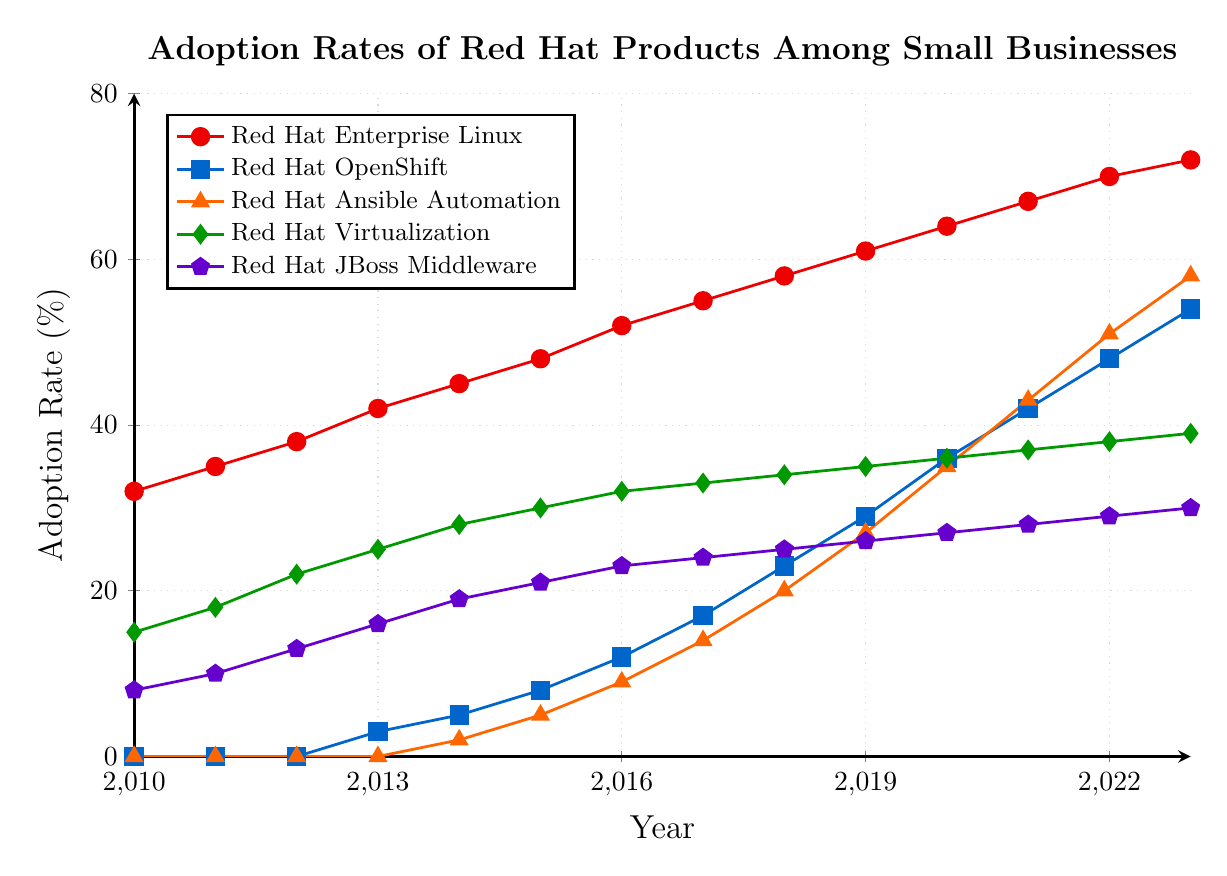What's the adoption rate of Red Hat Enterprise Linux in 2020? Locate the line corresponding to Red Hat Enterprise Linux and find the value at the year 2020, which is marked with a circular point. The y-axis value for this point is 64%.
Answer: 64% Which product had the lowest adoption rate in 2014? Compare the y-axis values for all product lines in the year 2014. Red Hat OpenShift had 5%, Red Hat Ansible Automation had 2%, Red Hat Virtualization had 28%, Red Hat JBoss Middleware had 19%, and Red Hat Enterprise Linux had 45%. The lowest is Red Hat Ansible Automation with 2%.
Answer: Red Hat Ansible Automation How does the adoption rate of Red Hat OpenShift in 2023 compare to that in 2015? The adoption rate of Red Hat OpenShift in 2023 is 54%, and in 2015 it is 8%. The adoption rate increased by 46%.
Answer: Increased by 46% Which product showed the greatest increase in adoption rate from 2010 to 2023? Calculate the difference in adoption rates from 2010 to 2023 for each product:
- Red Hat Enterprise Linux: 72 - 32 = 40%
- Red Hat OpenShift: 54 - 0 = 54%
- Red Hat Ansible Automation: 58 - 0 = 58%
- Red Hat Virtualization: 39 - 15 = 24%
- Red Hat JBoss Middleware: 30 - 8 = 22%
The greatest increase is in Red Hat Ansible Automation with an increase of 58%.
Answer: Red Hat Ansible Automation What is the average adoption rate of Red Hat Virtualization over the years 2018 to 2023? Sum the adoption rates for Red Hat Virtualization from 2018 to 2023: (34 + 35 + 36 + 37 + 38 + 39) = 219. Divide by the number of years, which is 6. So, the average is 219 / 6 ≈ 36.5%.
Answer: 36.5% Did any product other than Red Hat Ansible Automation have an adoption rate of 0% in any year after 2010? Review the lines for each product. Red Hat OpenShift had 0% until 2012, but after that, no product other than Red Hat Ansible Automation had 0% adoption rate.
Answer: No By how much did the adoption rate of Red Hat JBoss Middleware change between 2011 and 2021? The adoption rate of Red Hat JBoss Middleware in 2011 was 10%, and in 2021 it was 28%. The change is 28 - 10 = 18%.
Answer: 18% Which year did Red Hat Enterprise Linux first exceed an adoption rate of 50%? Follow the line for Red Hat Enterprise Linux and find the first year it exceeds 50%. This occurred in 2016, where the adoption rate reached 52%.
Answer: 2016 In which year did Red Hat Ansible Automation first surpass Red Hat Virtualization in adoption rates? Track the lines for both Red Hat Ansible Automation and Red Hat Virtualization. Red Hat Ansible Automation first surpassed Red Hat Virtualization in 2021, with 43% compared to 37% for Red Hat Virtualization.
Answer: 2021 